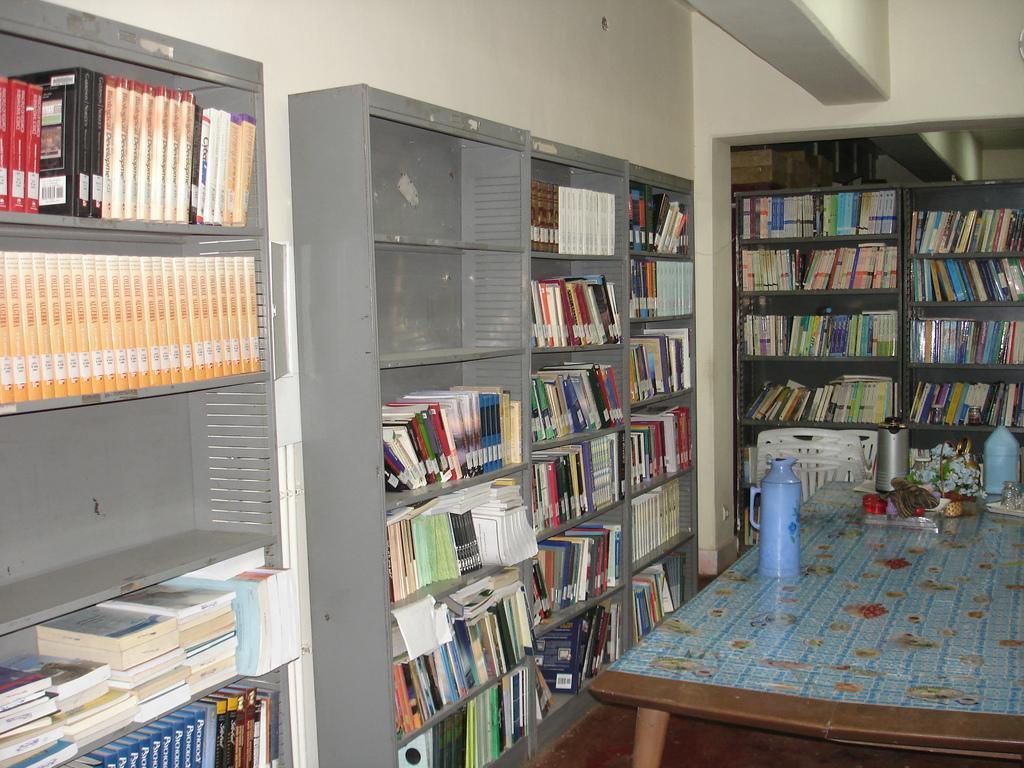How would you summarize this image in a sentence or two? In this picture we can see a table. On the table there is a bottle. Here we can see the rack. And there are some books in the rack. 